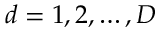<formula> <loc_0><loc_0><loc_500><loc_500>d = 1 , 2 , \dots , D</formula> 